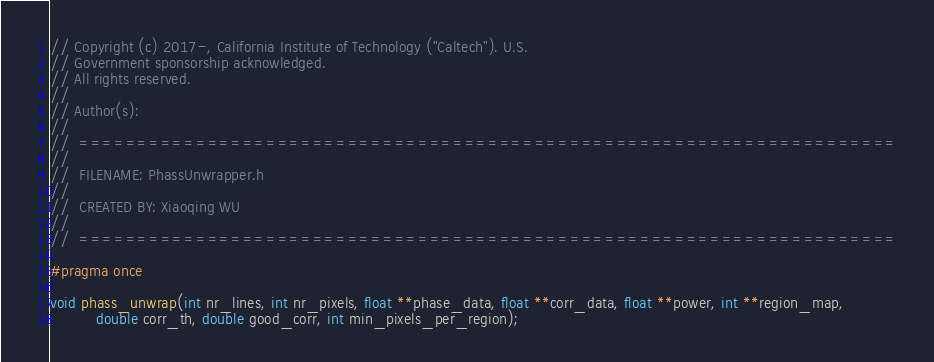<code> <loc_0><loc_0><loc_500><loc_500><_C_>// Copyright (c) 2017-, California Institute of Technology ("Caltech"). U.S.
// Government sponsorship acknowledged.
// All rights reserved.
// 
// Author(s):
// 
//  ======================================================================
// 
//  FILENAME: PhassUnwrapper.h
//   
//  CREATED BY: Xiaoqing WU
// 
//  ======================================================================

#pragma once

void phass_unwrap(int nr_lines, int nr_pixels, float **phase_data, float **corr_data, float **power, int **region_map,
		  double corr_th, double good_corr, int min_pixels_per_region);
</code> 